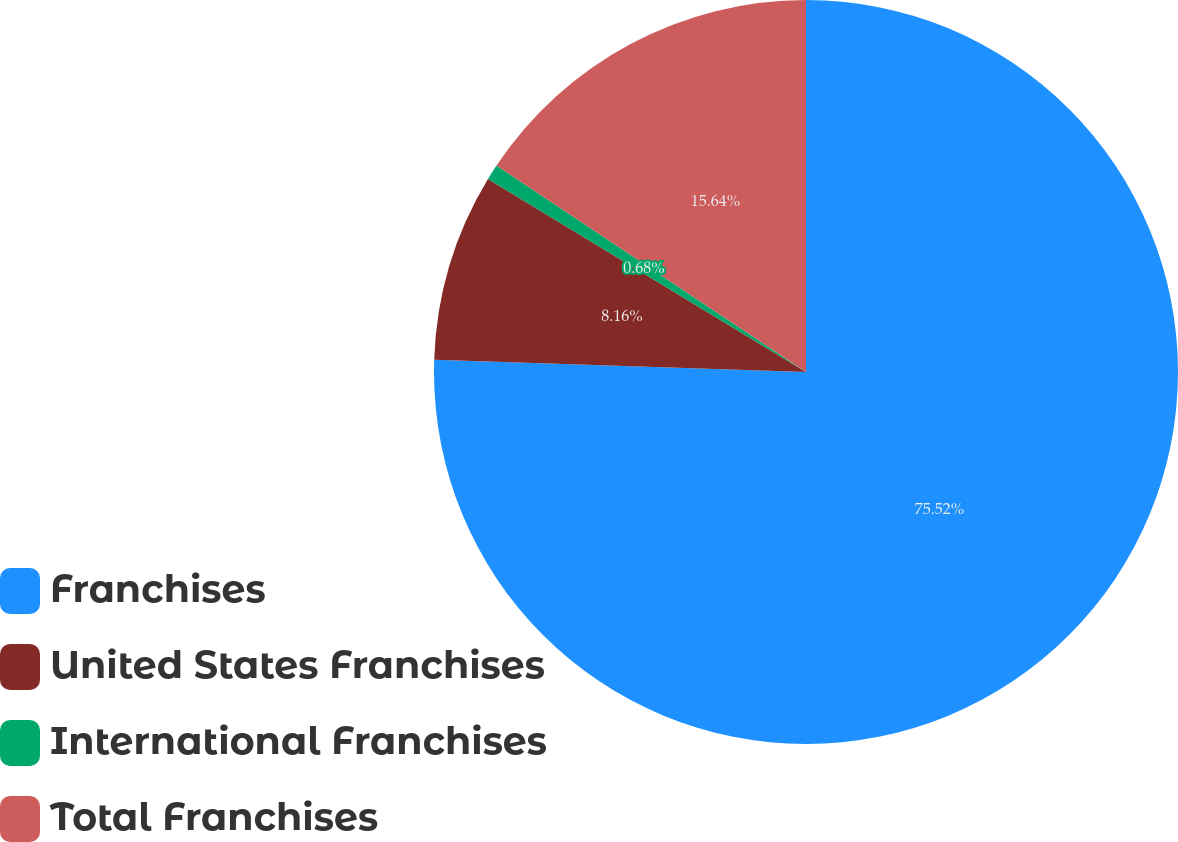Convert chart to OTSL. <chart><loc_0><loc_0><loc_500><loc_500><pie_chart><fcel>Franchises<fcel>United States Franchises<fcel>International Franchises<fcel>Total Franchises<nl><fcel>75.52%<fcel>8.16%<fcel>0.68%<fcel>15.64%<nl></chart> 